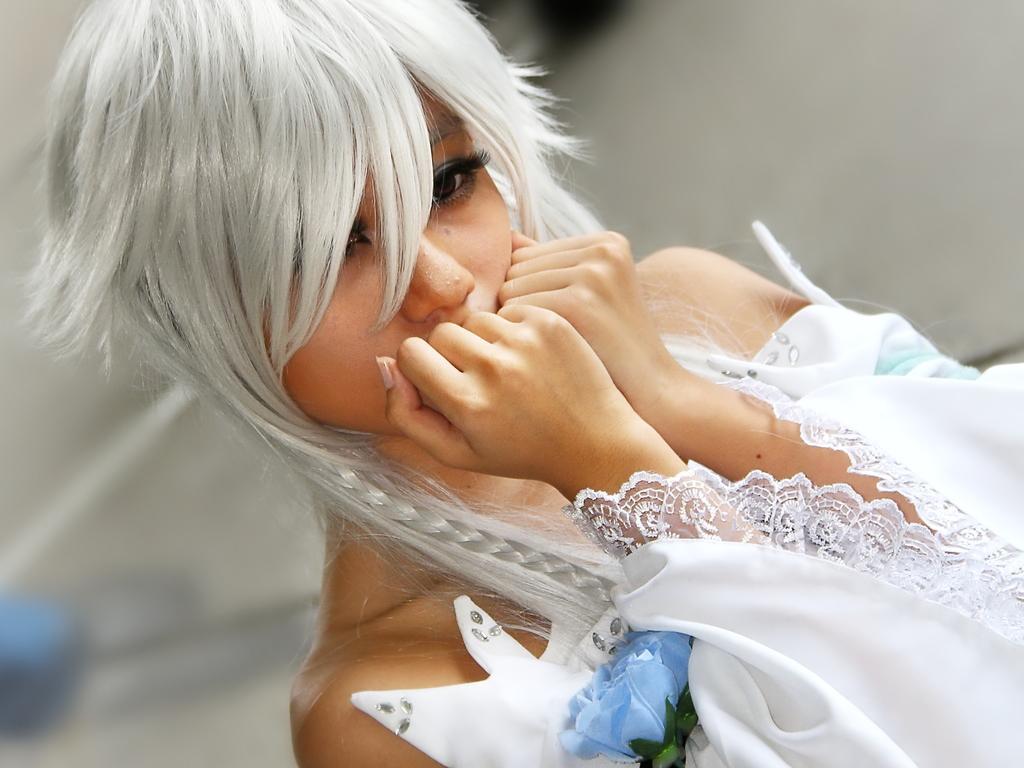Can you describe this image briefly? In this image in front there is a person and the background of the image is blur. 